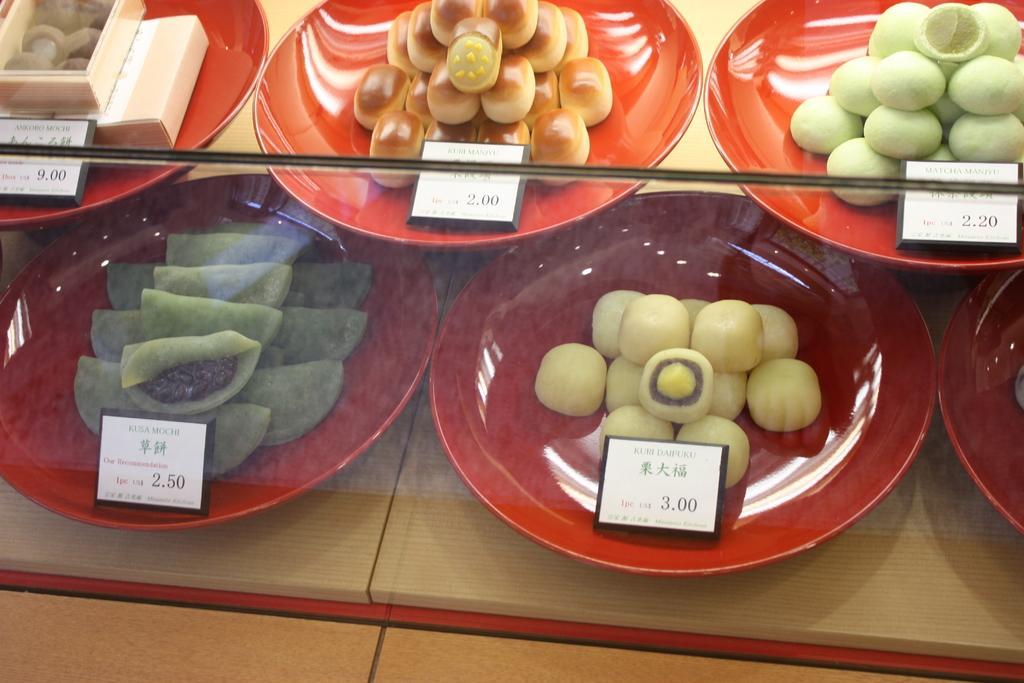What can be seen on the plates in the image? There is food placed in different plates in the image. What additional details are provided in the image? Information labels are present in the image. What type of tank is visible in the image? There is no tank present in the image. 